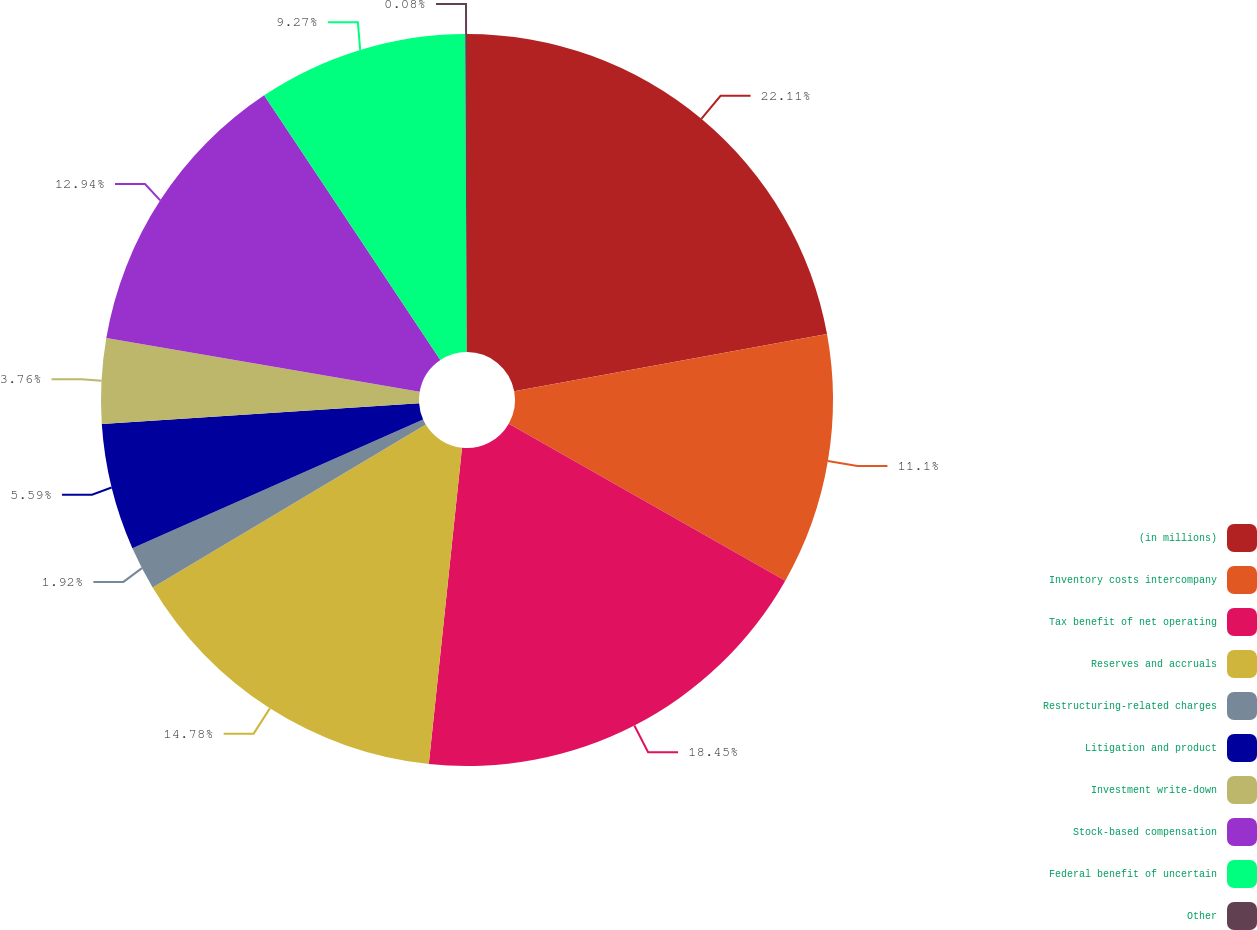Convert chart to OTSL. <chart><loc_0><loc_0><loc_500><loc_500><pie_chart><fcel>(in millions)<fcel>Inventory costs intercompany<fcel>Tax benefit of net operating<fcel>Reserves and accruals<fcel>Restructuring-related charges<fcel>Litigation and product<fcel>Investment write-down<fcel>Stock-based compensation<fcel>Federal benefit of uncertain<fcel>Other<nl><fcel>22.12%<fcel>11.1%<fcel>18.45%<fcel>14.78%<fcel>1.92%<fcel>5.59%<fcel>3.76%<fcel>12.94%<fcel>9.27%<fcel>0.08%<nl></chart> 